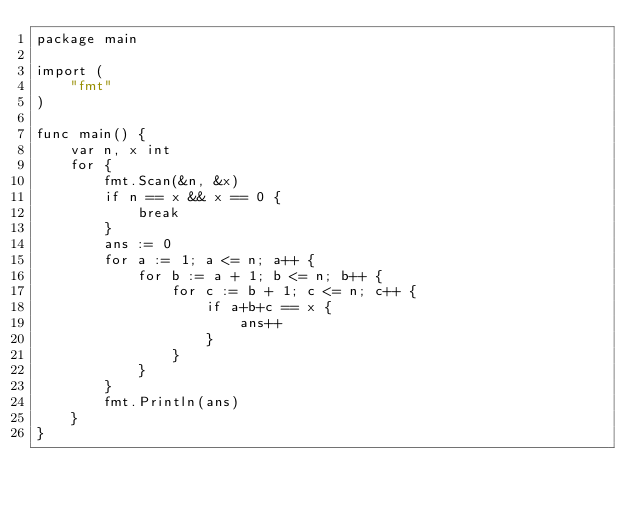<code> <loc_0><loc_0><loc_500><loc_500><_Go_>package main

import (
	"fmt"
)

func main() {
	var n, x int
	for {
		fmt.Scan(&n, &x)
		if n == x && x == 0 {
			break
		}
		ans := 0
		for a := 1; a <= n; a++ {
			for b := a + 1; b <= n; b++ {
				for c := b + 1; c <= n; c++ {
					if a+b+c == x {
						ans++
					}
				}
			}
		}
		fmt.Println(ans)
	}
}

</code> 